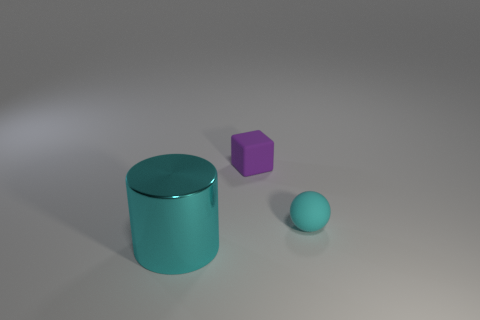Add 1 cubes. How many objects exist? 4 Subtract all cubes. How many objects are left? 2 Subtract all brown blocks. Subtract all cyan balls. How many blocks are left? 1 Subtract all small balls. Subtract all shiny objects. How many objects are left? 1 Add 1 cyan metal cylinders. How many cyan metal cylinders are left? 2 Add 3 small cyan matte objects. How many small cyan matte objects exist? 4 Subtract 0 blue balls. How many objects are left? 3 